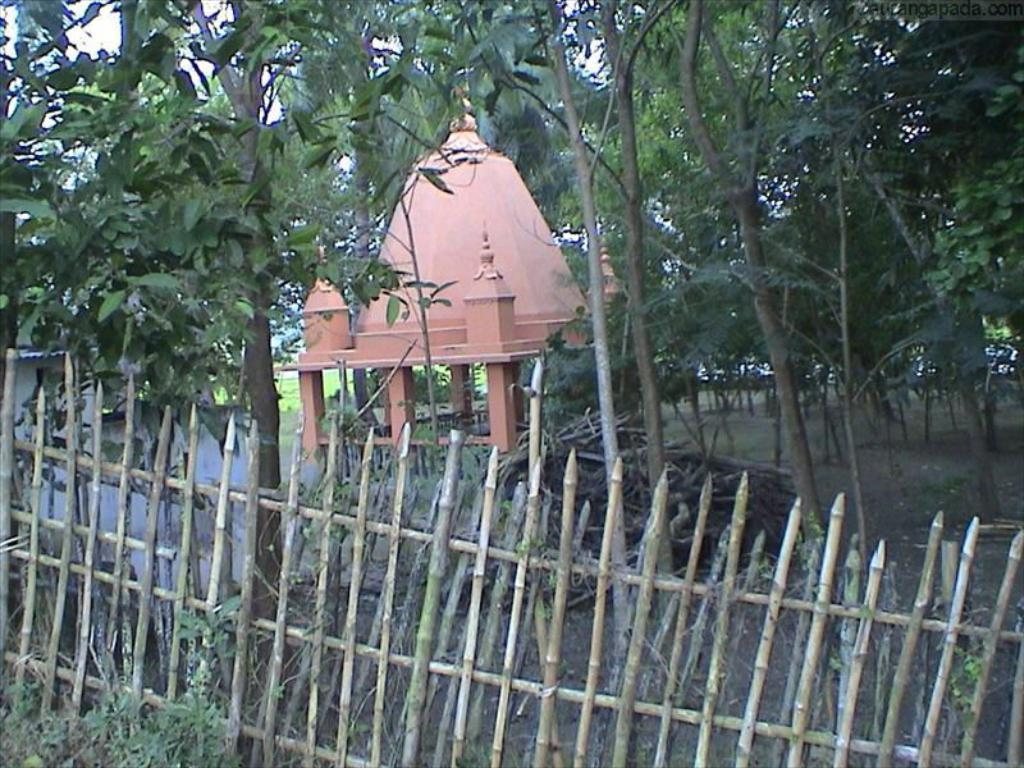What type of material is used for the railing in the image? The wooden railing in the image is made of wood. What can be seen in the background of the image? There are trees and a shelter in the background of the image. What type of flooring can be seen under the railing in the image? There is no flooring visible under the railing in the image; it appears to be a wooden railing on a raised platform or structure. 